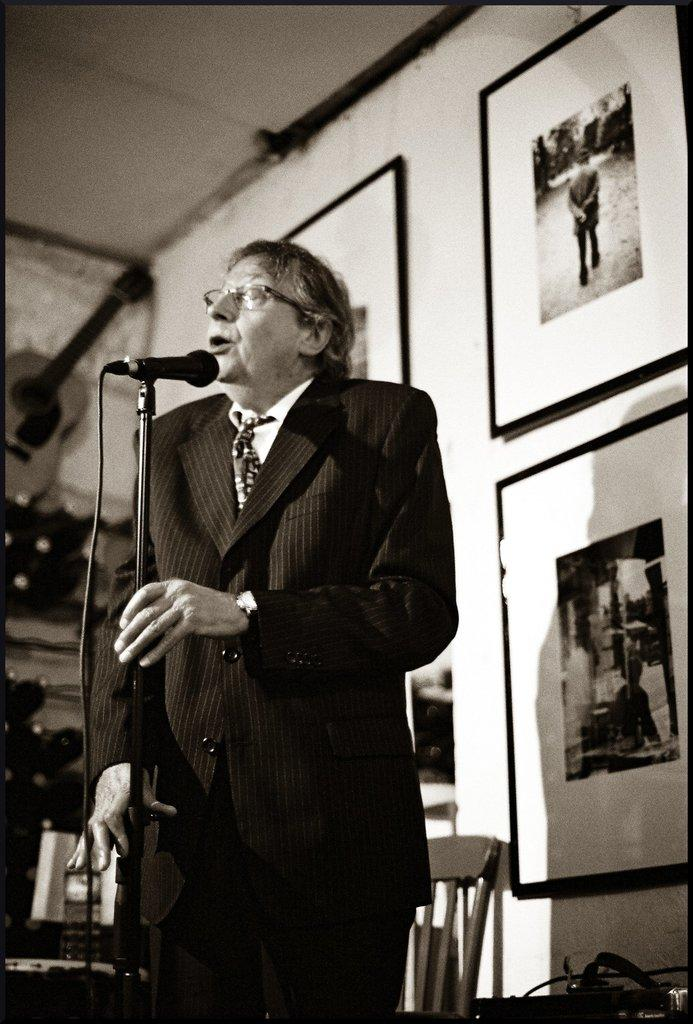What is the main subject of the image? There is a man standing in the center of the image. What is the man doing in the image? The man is speaking in front of a mic. What can be seen in the background of the image? There are frames on the wall and a chair in the background of the image. What direction is the store facing in the image? There is no store present in the image. What sense is the man using to communicate in the image? The man is using his sense of speech to communicate in the image. 